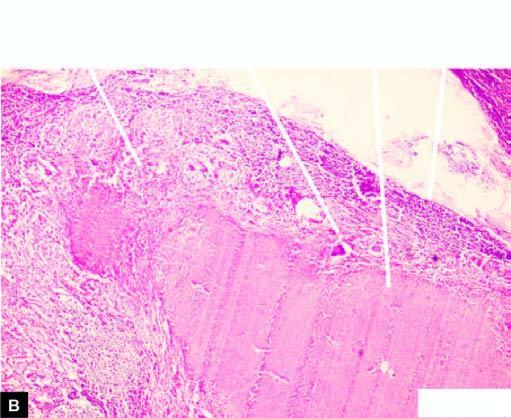does section of matted mass of lymph nodes show merging capsules and large areas of caseation necrosis?
Answer the question using a single word or phrase. Yes 